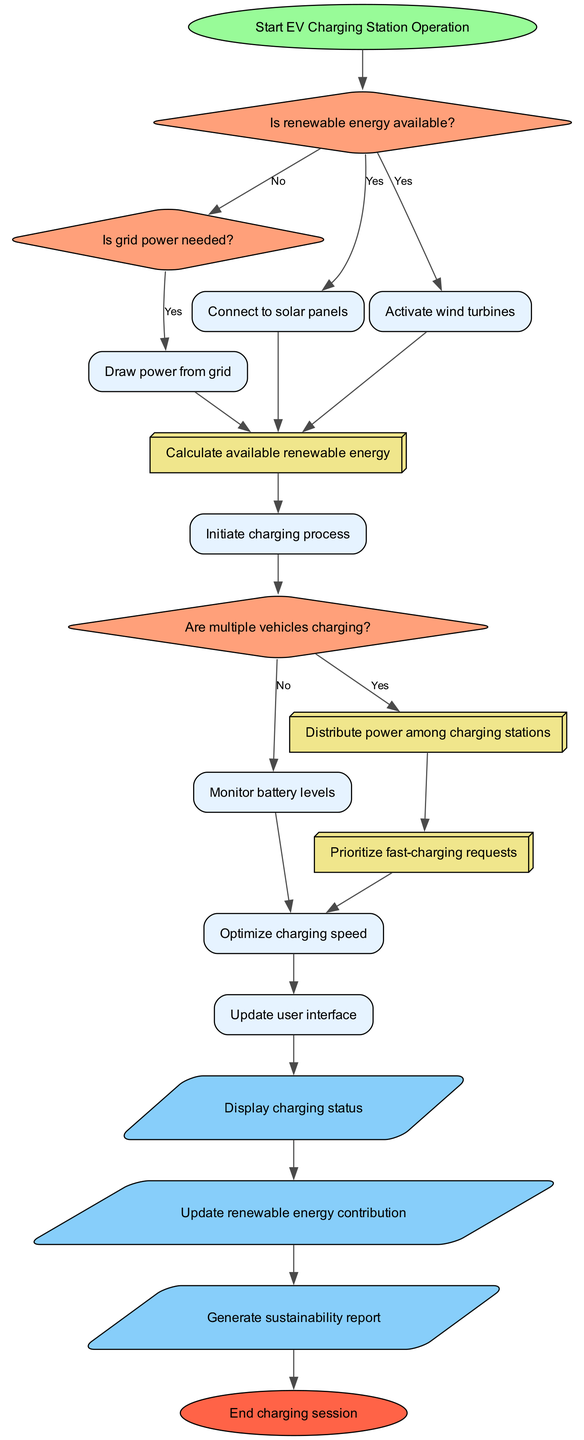What is the starting point of the flowchart? The flowchart begins at the node labeled "Start EV Charging Station Operation," which initiates the entire process.
Answer: Start EV Charging Station Operation How many decision nodes are present in the flowchart? There are three decision nodes labeled "Is renewable energy available?", "Is grid power needed?", and "Are multiple vehicles charging?", making a total of three.
Answer: 3 What is the last output shown in the diagram? The last output node is labeled "Generate sustainability report," indicating the final report generated at the end of the process.
Answer: Generate sustainability report What process follows after connecting to solar panels? After connecting to solar panels, the flow proceeds to activate wind turbines based on the answer to the decision about renewable energy availability.
Answer: Activate wind turbines What happens if multiple vehicles are charging? If multiple vehicles are charging, the flow goes to the subprocess "Distribute power among charging stations," indicating that power is allocated between the charging stations.
Answer: Distribute power among charging stations What is the purpose of the subprocess "Calculate available renewable energy"? The subprocess "Calculate available renewable energy" is essential as it determines the amount of energy available from renewable sources, which influences the charging process decisions.
Answer: Determines renewable energy availability How is the user interface updated in the flowchart logic? The user interface is updated after completing the charging process, and it displays information from the charging status, renewable energy contribution, and sustainability report.
Answer: Display charging status What occurs after initiating the charging process? After initiating the charging process, the flow checks if multiple vehicles are charging, leading to further decision-making regarding load balancing.
Answer: Check for multiple vehicles charging What type of node is "Draw power from grid"? "Draw power from grid" is classified as a process node in the flowchart, indicating an action taken during the charging station's operation.
Answer: Process node 